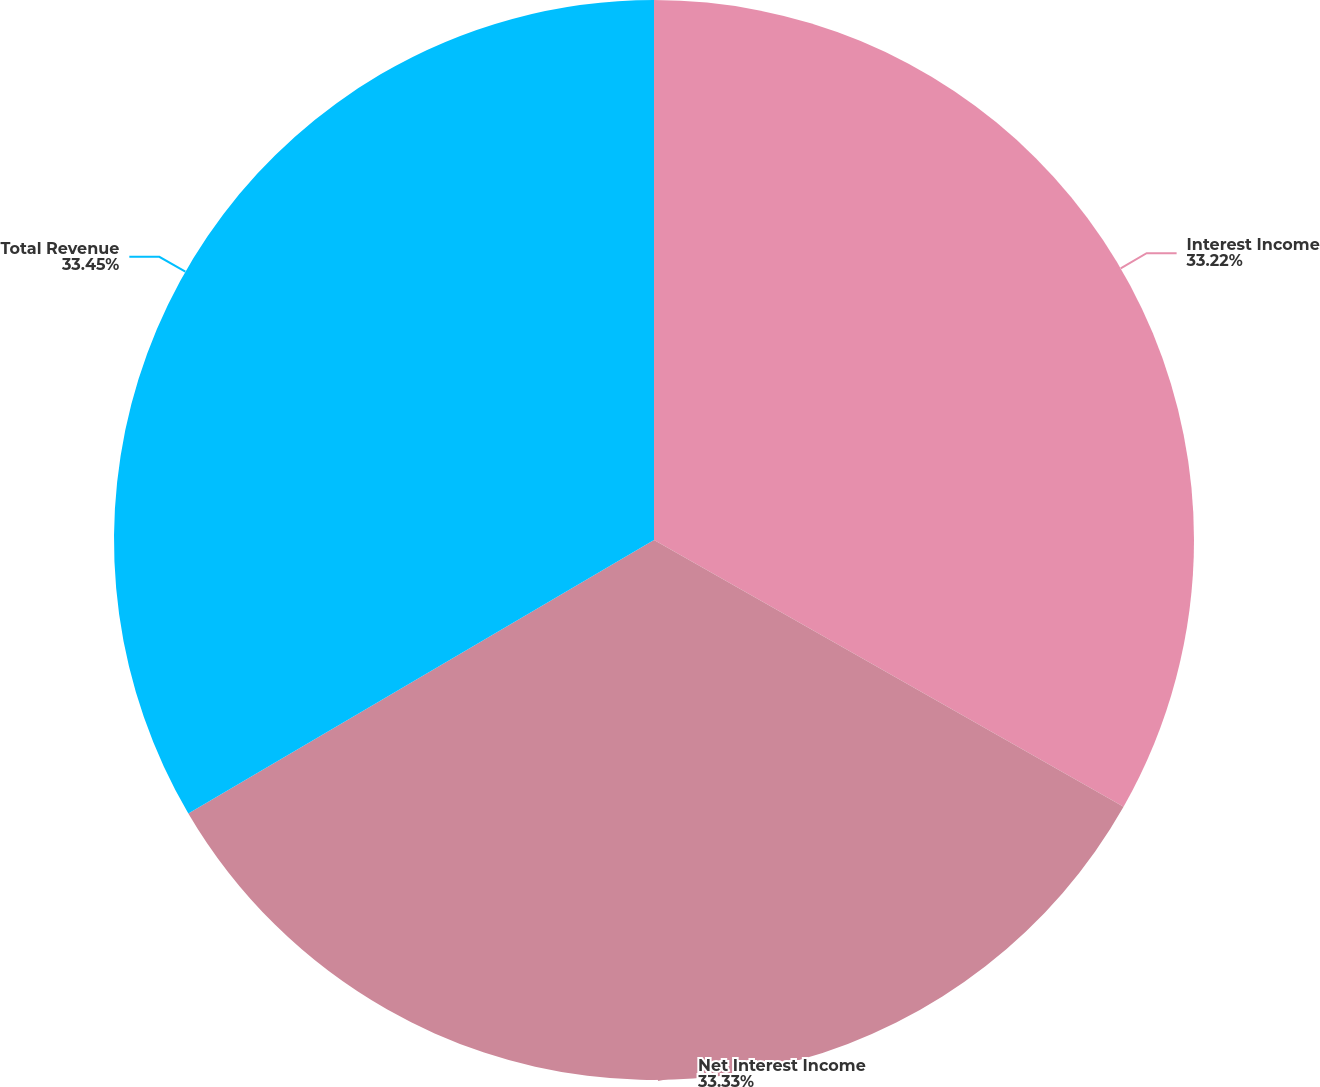Convert chart. <chart><loc_0><loc_0><loc_500><loc_500><pie_chart><fcel>Interest Income<fcel>Net Interest Income<fcel>Total Revenue<nl><fcel>33.22%<fcel>33.33%<fcel>33.45%<nl></chart> 